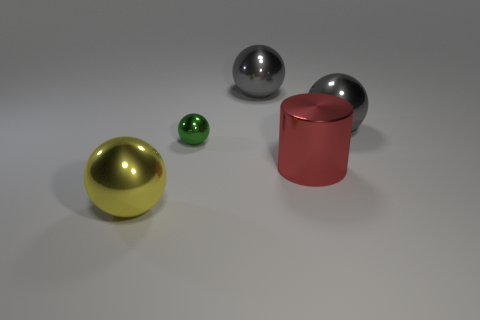Which object in the image seems to reflect its surroundings most clearly? The large gray sphere on the right side reflects its surroundings with the highest clarity, as you can see the crisp reflections of the environment on its polished metallic surface. 